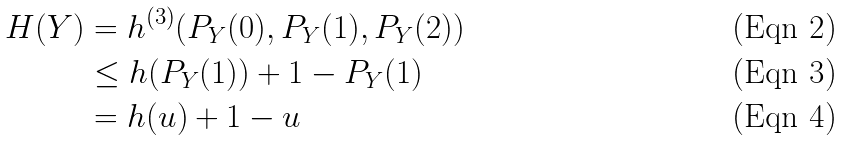<formula> <loc_0><loc_0><loc_500><loc_500>H ( Y ) & = h ^ { ( 3 ) } ( P _ { Y } ( 0 ) , P _ { Y } ( 1 ) , P _ { Y } ( 2 ) ) \\ & \leq h ( P _ { Y } ( 1 ) ) + 1 - P _ { Y } ( 1 ) \\ & = h ( u ) + 1 - u</formula> 